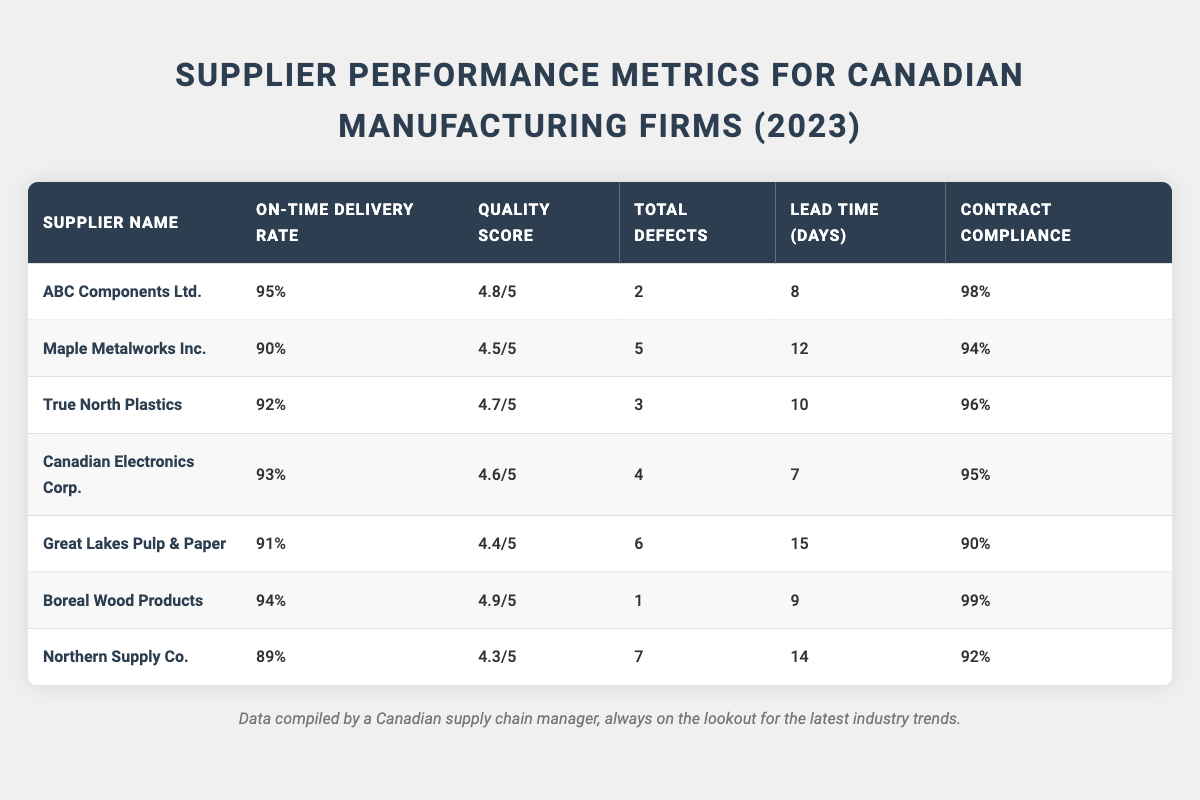What is the on-time delivery rate of Boreal Wood Products? The table shows that Boreal Wood Products has an On-Time Delivery Rate of 94%.
Answer: 94% Which supplier has the lowest quality score? Among the suppliers listed, Northern Supply Co. has the lowest Quality Score of 4.3/5.
Answer: Northern Supply Co How many total defects did Great Lakes Pulp & Paper have? According to the table, Great Lakes Pulp & Paper reported a total of 6 defects.
Answer: 6 What is the average lead time for the listed suppliers? The lead times for all suppliers are: 8, 12, 10, 7, 15, 9, 14 days. Adding these gives 75 days, and dividing by 7 suppliers gives an average of 75/7 ≈ 10.71 days.
Answer: Approximately 10.71 days Which supplier has the highest contract compliance percentage? The highest contract compliance percentage recorded in the table is 99%, achieved by Boreal Wood Products.
Answer: 99% True or False: Canadian Electronics Corp. has a total of 4 defects. The information provided in the table confirms that Canadian Electronics Corp. has a total of 4 defects, making the statement true.
Answer: True What is the difference in on-time delivery rate between ABC Components Ltd. and Northern Supply Co.? ABC Components Ltd. has an on-time delivery rate of 95%, while Northern Supply Co. has 89%. The difference is 95% - 89% = 6%.
Answer: 6% Which supplier has a higher quality score, True North Plastics or Maple Metalworks Inc.? True North Plastics has a Quality Score of 4.7/5, while Maple Metalworks Inc. has 4.5/5, indicating that True North Plastics is higher.
Answer: True North Plastics Identify the supplier with the longest lead time. The longest lead time found in the data is 15 days for Great Lakes Pulp & Paper.
Answer: Great Lakes Pulp & Paper What total number of defects do ABC Components Ltd. and Boreal Wood Products have together? ABC Components Ltd. has 2 defects and Boreal Wood Products has 1 defect. Adding these results in a total of 2 + 1 = 3 defects.
Answer: 3 